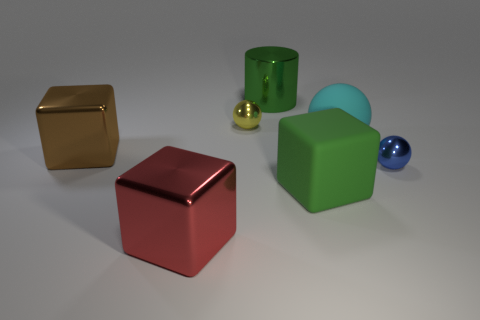Subtract all gray cubes. Subtract all gray cylinders. How many cubes are left? 3 Add 1 cyan things. How many objects exist? 8 Subtract all cubes. How many objects are left? 4 Subtract all cyan balls. Subtract all red metal things. How many objects are left? 5 Add 7 large cyan things. How many large cyan things are left? 8 Add 5 large cyan objects. How many large cyan objects exist? 6 Subtract 0 red spheres. How many objects are left? 7 